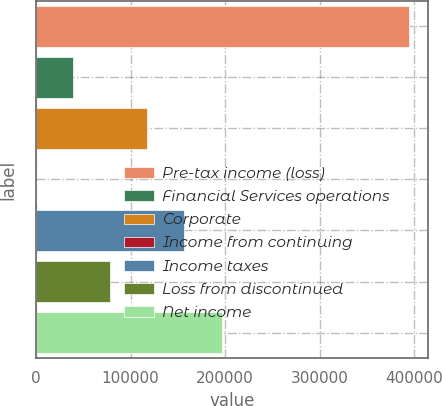<chart> <loc_0><loc_0><loc_500><loc_500><bar_chart><fcel>Pre-tax income (loss)<fcel>Financial Services operations<fcel>Corporate<fcel>Income from continuing<fcel>Income taxes<fcel>Loss from discontinued<fcel>Net income<nl><fcel>394334<fcel>39243<fcel>117719<fcel>5.18<fcel>156956<fcel>78480.7<fcel>196194<nl></chart> 